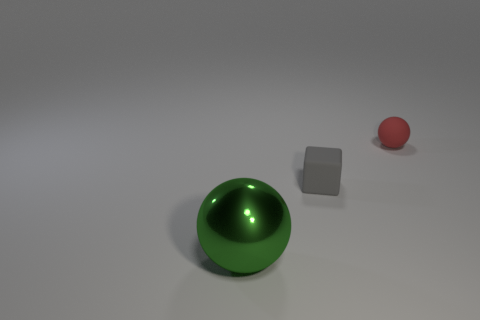How many tiny matte blocks have the same color as the big sphere?
Give a very brief answer. 0. The large shiny object that is the same shape as the red rubber thing is what color?
Give a very brief answer. Green. Are there more tiny gray objects than small metal spheres?
Your answer should be very brief. Yes. What material is the big green object?
Provide a short and direct response. Metal. Are there any other things that are the same size as the matte cube?
Provide a succinct answer. Yes. There is a green thing that is the same shape as the tiny red thing; what is its size?
Make the answer very short. Large. Is there a big green shiny sphere that is on the right side of the ball that is behind the green metal thing?
Provide a short and direct response. No. Does the matte ball have the same color as the block?
Your answer should be very brief. No. How many other objects are the same shape as the red object?
Provide a short and direct response. 1. Is the number of small gray matte things left of the small gray rubber object greater than the number of green spheres that are to the right of the tiny red rubber ball?
Provide a succinct answer. No. 